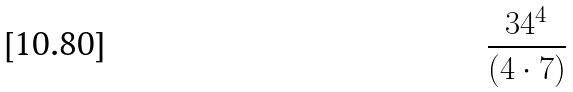<formula> <loc_0><loc_0><loc_500><loc_500>\frac { 3 4 ^ { 4 } } { ( 4 \cdot 7 ) }</formula> 